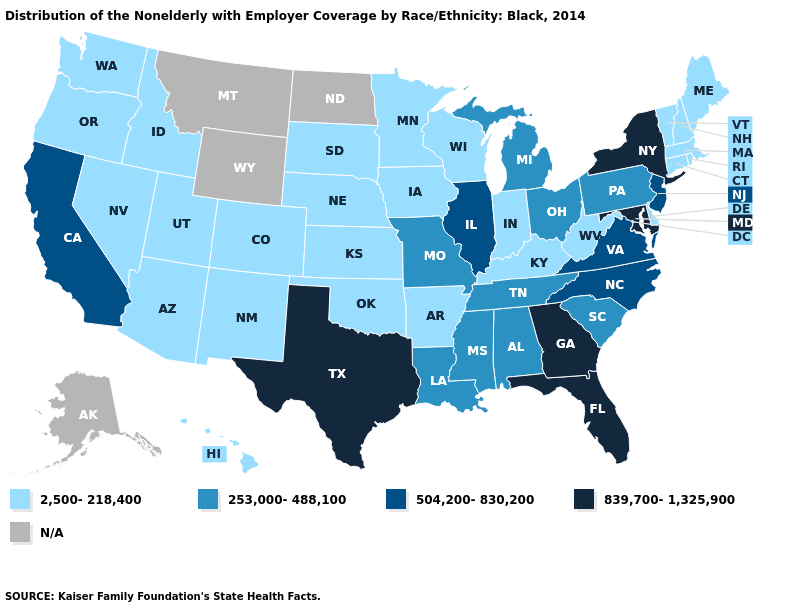What is the value of Kansas?
Be succinct. 2,500-218,400. Is the legend a continuous bar?
Quick response, please. No. What is the value of Oregon?
Concise answer only. 2,500-218,400. Name the states that have a value in the range 839,700-1,325,900?
Write a very short answer. Florida, Georgia, Maryland, New York, Texas. What is the value of Oregon?
Quick response, please. 2,500-218,400. What is the value of Virginia?
Quick response, please. 504,200-830,200. What is the highest value in the USA?
Answer briefly. 839,700-1,325,900. Which states have the lowest value in the Northeast?
Short answer required. Connecticut, Maine, Massachusetts, New Hampshire, Rhode Island, Vermont. Among the states that border Connecticut , which have the lowest value?
Be succinct. Massachusetts, Rhode Island. What is the value of Nebraska?
Be succinct. 2,500-218,400. Name the states that have a value in the range 504,200-830,200?
Keep it brief. California, Illinois, New Jersey, North Carolina, Virginia. Among the states that border Virginia , which have the highest value?
Be succinct. Maryland. What is the lowest value in the USA?
Keep it brief. 2,500-218,400. What is the value of Colorado?
Short answer required. 2,500-218,400. What is the value of Michigan?
Give a very brief answer. 253,000-488,100. 